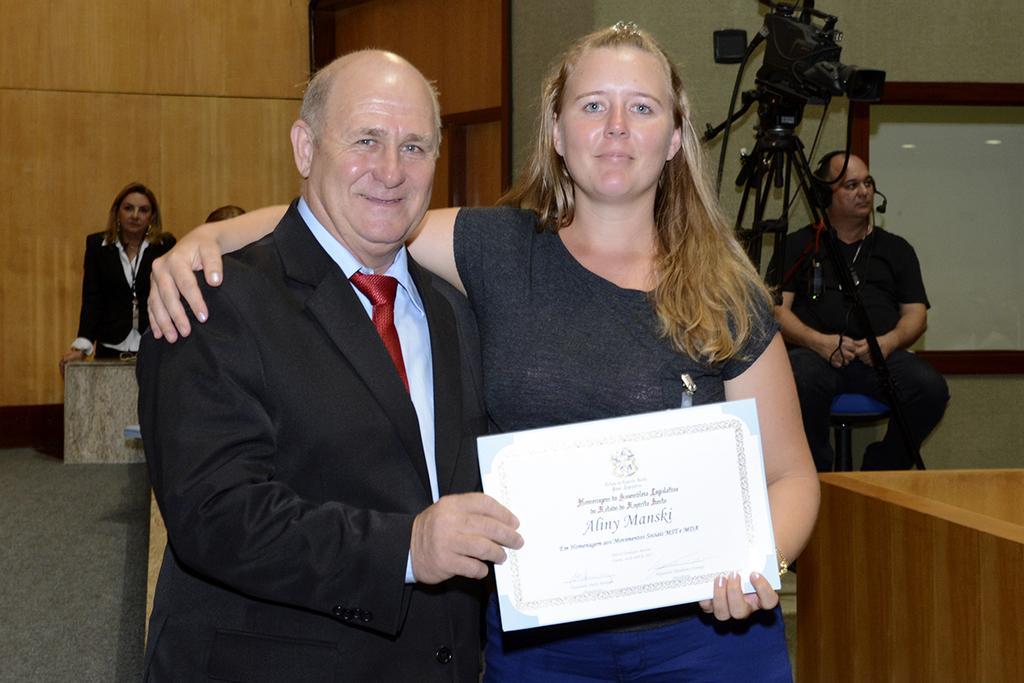Please provide a concise description of this image. In this image I can see a woman is holding the certificate in her hand, she wore t-shirt, trouser. Beside her a man is there, he wore tie, shirt, coat. 